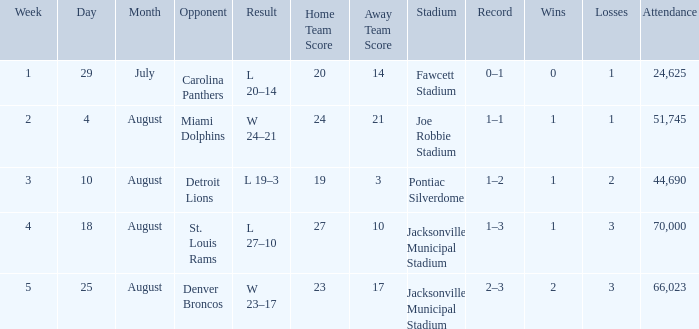What is the Record in Week 2? 1–1. 